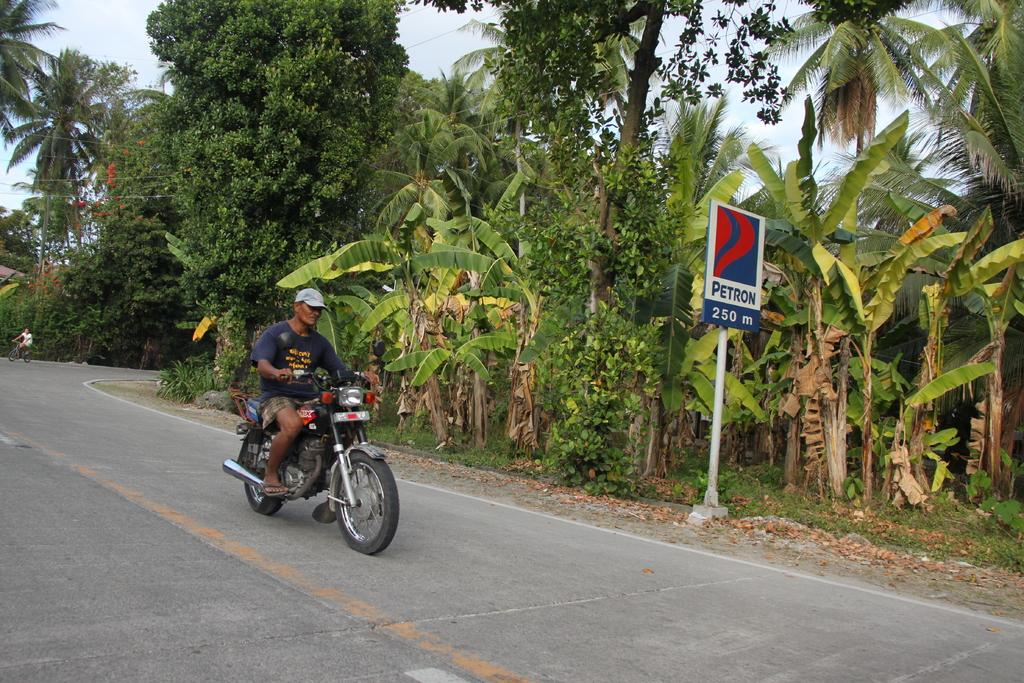What is the person in the image wearing? The person in the image is wearing a blue shirt. What activity is the person in the image engaged in? The person is riding a bike. Where is the bike located in the image? The bike is on the road. What can be seen beside the person in the image? There are trees beside the person. Can you describe the background of the image? In the background, there is another person riding a bicycle. What month is it in the image? The provided facts do not mention the month, so it cannot be determined from the image. Can you describe the carriage in the image? There is no carriage present in the image. 